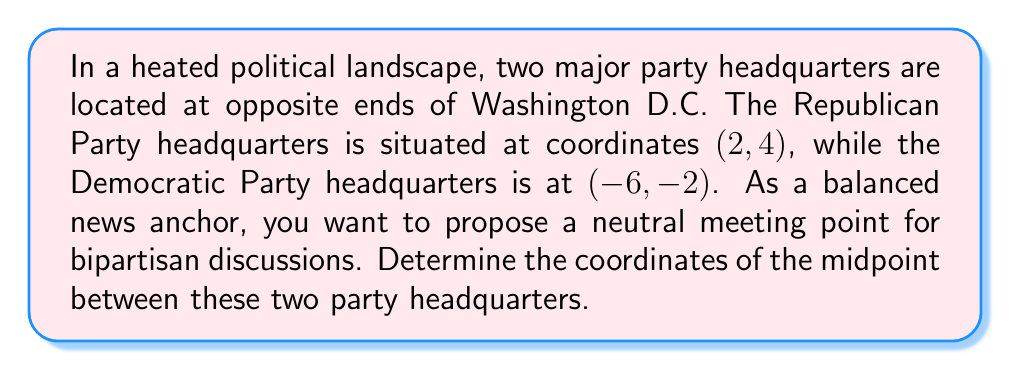Give your solution to this math problem. To find the midpoint of a line segment connecting two points, we use the midpoint formula:

$$\text{Midpoint} = \left(\frac{x_1 + x_2}{2}, \frac{y_1 + y_2}{2}\right)$$

Where $(x_1, y_1)$ represents the coordinates of the first point, and $(x_2, y_2)$ represents the coordinates of the second point.

In this case:
- Republican Party headquarters: $(x_1, y_1) = (2, 4)$
- Democratic Party headquarters: $(x_2, y_2) = (-6, -2)$

Let's substitute these values into the midpoint formula:

$$\text{Midpoint} = \left(\frac{2 + (-6)}{2}, \frac{4 + (-2)}{2}\right)$$

Simplifying:

$$\text{Midpoint} = \left(\frac{-4}{2}, \frac{2}{2}\right)$$

$$\text{Midpoint} = (-2, 1)$$

[asy]
unitsize(1cm);
draw((-7,-3)--(3,5), gray);
dot((2,4), red);
dot((-6,-2), blue);
dot((-2,1), green);
label("Republican HQ (2, 4)", (2,4), NE, red);
label("Democratic HQ (-6, -2)", (-6,-2), SW, blue);
label("Midpoint (-2, 1)", (-2,1), SE, green);
[/asy]

This midpoint represents a balanced location between the two party headquarters, symbolizing a neutral ground for bipartisan discussions.
Answer: The midpoint of the line segment connecting the two party headquarters is $(-2, 1)$. 